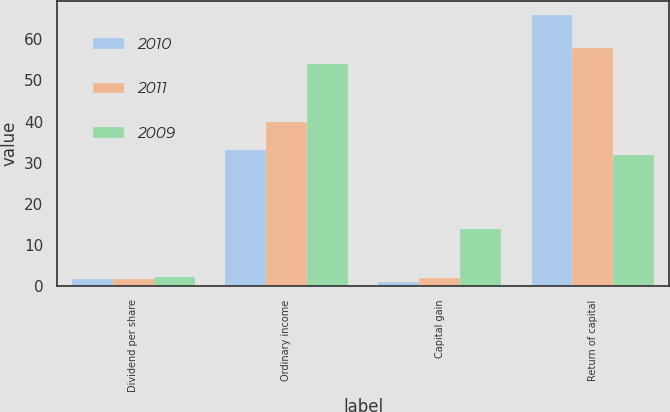Convert chart to OTSL. <chart><loc_0><loc_0><loc_500><loc_500><stacked_bar_chart><ecel><fcel>Dividend per share<fcel>Ordinary income<fcel>Capital gain<fcel>Return of capital<nl><fcel>2010<fcel>1.85<fcel>33<fcel>1<fcel>66<nl><fcel>2011<fcel>1.85<fcel>40<fcel>2<fcel>58<nl><fcel>2009<fcel>2.11<fcel>54<fcel>14<fcel>32<nl></chart> 